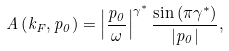<formula> <loc_0><loc_0><loc_500><loc_500>A \left ( k _ { F } , p _ { 0 } \right ) = \left | \frac { p _ { 0 } } { \omega } \right | ^ { \gamma ^ { * } } \frac { \sin \left ( \pi \gamma ^ { * } \right ) } { \left | p _ { 0 } \right | } ,</formula> 